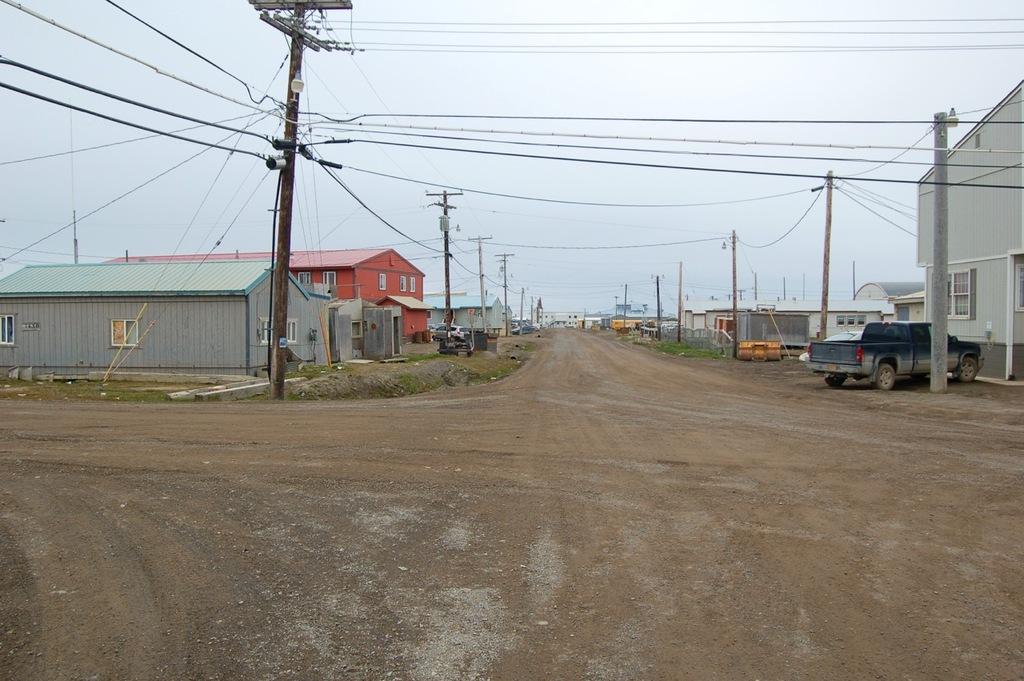How would you summarize this image in a sentence or two? Here in this picture we can see vehicles present on the road and beside that on either side we can see houses and sheds present and we can also see electric poles, through which wires are hanging and we can see the sky is cloudy and we can also see some part of ground is covered with grass and plants. 